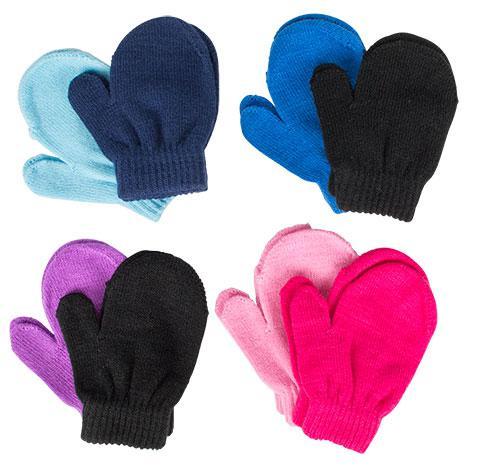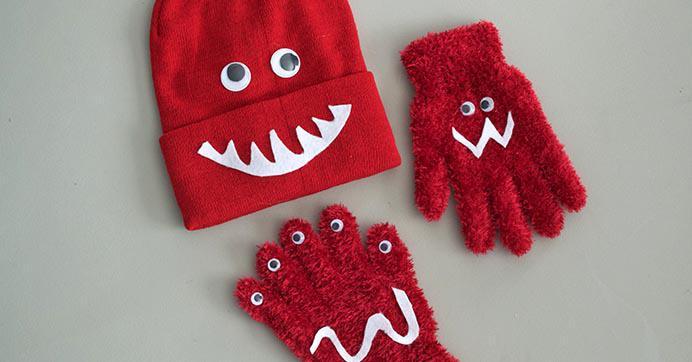The first image is the image on the left, the second image is the image on the right. For the images displayed, is the sentence "An image shows exactly three unworn items of apparel, and at least two are gloves with fingers." factually correct? Answer yes or no. Yes. The first image is the image on the left, the second image is the image on the right. Analyze the images presented: Is the assertion "The left and right image contains the same number of red mittens." valid? Answer yes or no. No. 